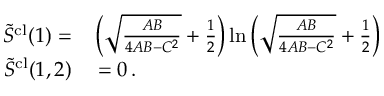<formula> <loc_0><loc_0><loc_500><loc_500>\begin{array} { r l } { \tilde { S } ^ { c l } ( 1 ) = } & \left ( \sqrt { \frac { A B } { 4 A B - C ^ { 2 } } } + \frac { 1 } { 2 } \right ) \ln \left ( \sqrt { \frac { A B } { 4 A B - C ^ { 2 } } } + \frac { 1 } { 2 } \right ) } \\ { \tilde { S } ^ { c l } ( 1 , 2 ) } & = 0 \, . } \end{array}</formula> 